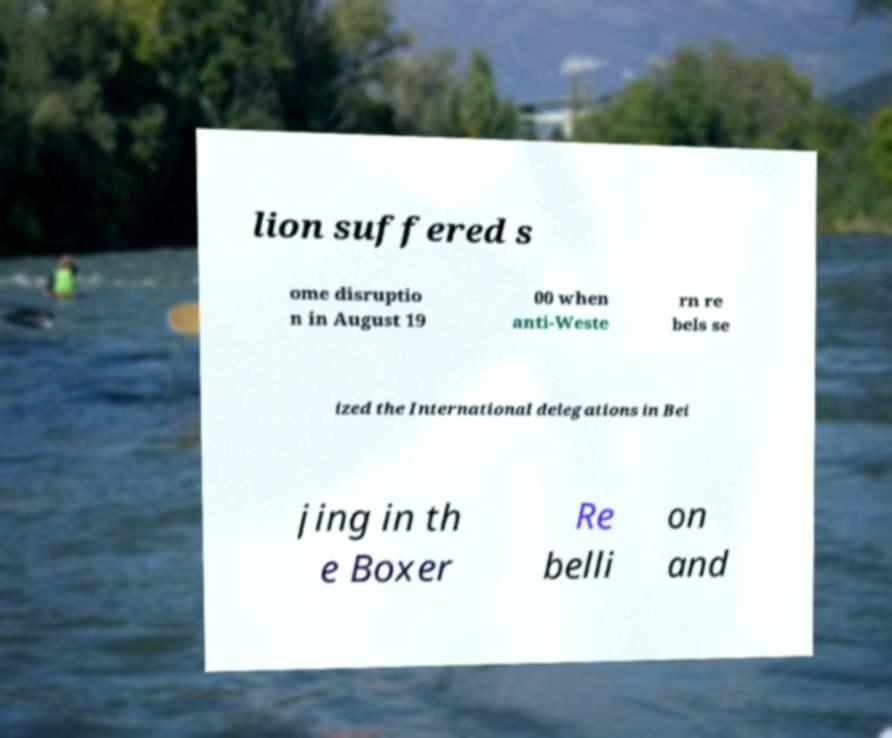What messages or text are displayed in this image? I need them in a readable, typed format. lion suffered s ome disruptio n in August 19 00 when anti-Weste rn re bels se ized the International delegations in Bei jing in th e Boxer Re belli on and 